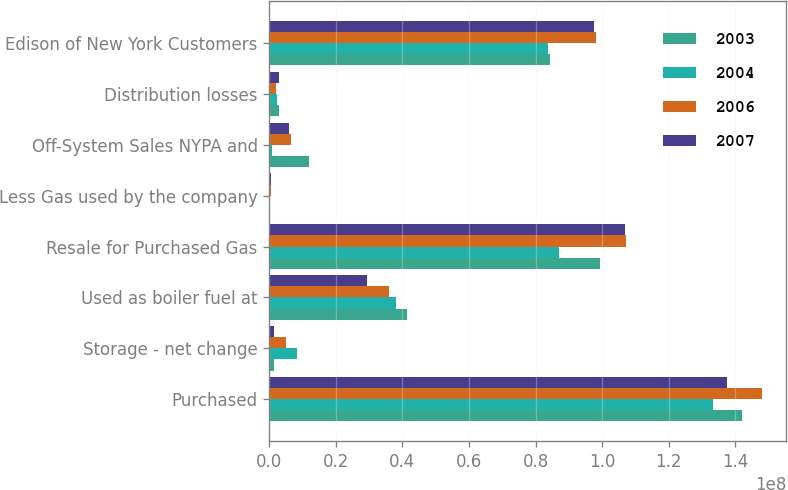Convert chart to OTSL. <chart><loc_0><loc_0><loc_500><loc_500><stacked_bar_chart><ecel><fcel>Purchased<fcel>Storage - net change<fcel>Used as boiler fuel at<fcel>Resale for Purchased Gas<fcel>Less Gas used by the company<fcel>Off-System Sales NYPA and<fcel>Distribution losses<fcel>Edison of New York Customers<nl><fcel>2003<fcel>1.4184e+08<fcel>1.27352e+06<fcel>4.12568e+07<fcel>9.93093e+07<fcel>144236<fcel>1.18432e+07<fcel>3.01e+06<fcel>8.43118e+07<nl><fcel>2004<fcel>1.33396e+08<fcel>8.29472e+06<fcel>3.80614e+07<fcel>8.70394e+07<fcel>120626<fcel>724748<fcel>2.34e+06<fcel>8.3854e+07<nl><fcel>2006<fcel>1.47855e+08<fcel>5.04132e+06<fcel>3.58202e+07<fcel>1.06994e+08<fcel>366780<fcel>6.44972e+06<fcel>2.074e+06<fcel>9.81031e+07<nl><fcel>2007<fcel>1.37606e+08<fcel>1.33115e+06<fcel>2.94359e+07<fcel>1.06839e+08<fcel>364142<fcel>6.06214e+06<fcel>2.769e+06<fcel>9.76434e+07<nl></chart> 